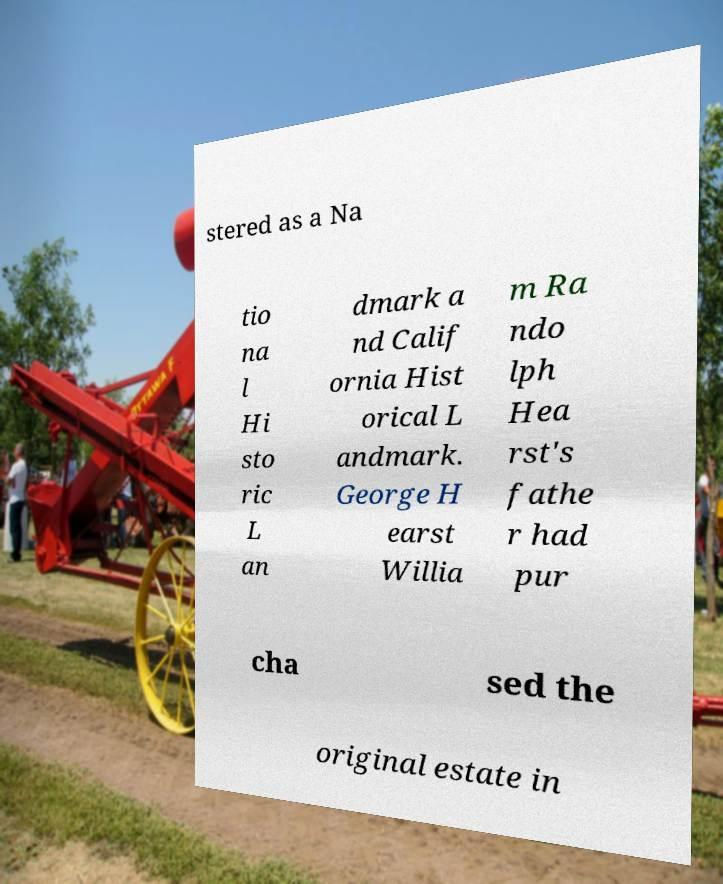Please read and relay the text visible in this image. What does it say? stered as a Na tio na l Hi sto ric L an dmark a nd Calif ornia Hist orical L andmark. George H earst Willia m Ra ndo lph Hea rst's fathe r had pur cha sed the original estate in 